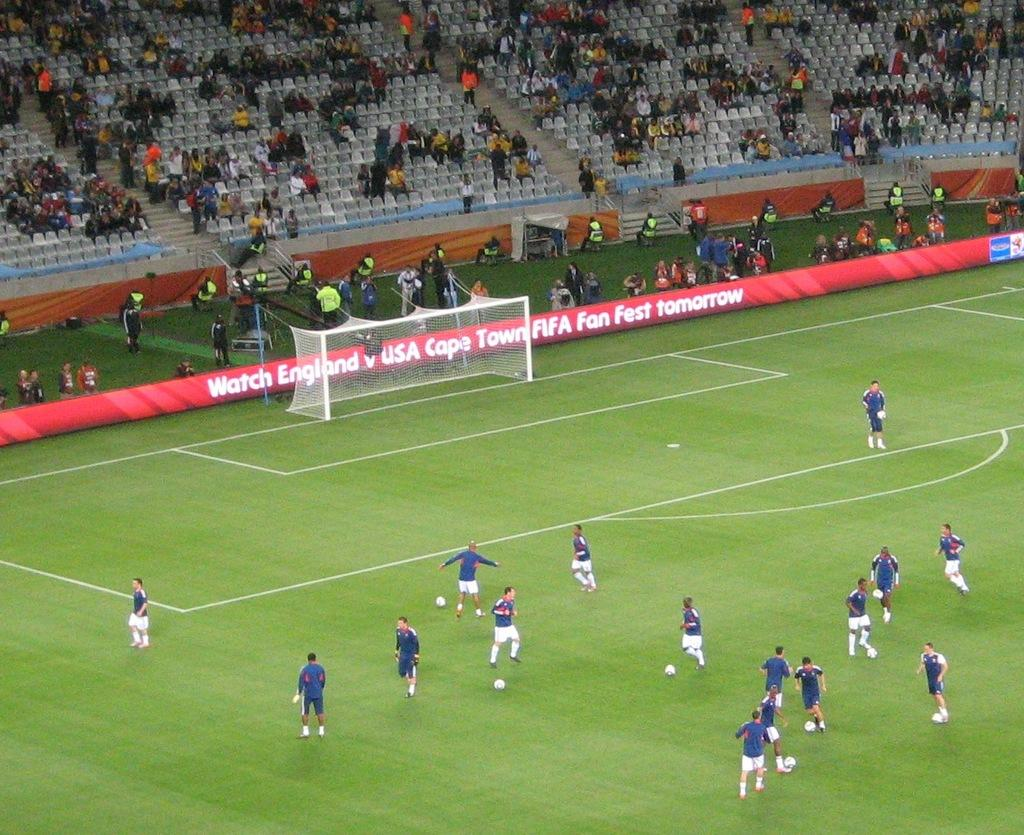<image>
Provide a brief description of the given image. A banner advertising FIFA appears around a soccer field. 